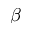<formula> <loc_0><loc_0><loc_500><loc_500>\beta</formula> 